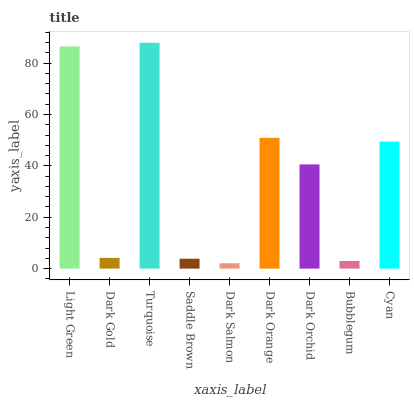Is Dark Salmon the minimum?
Answer yes or no. Yes. Is Turquoise the maximum?
Answer yes or no. Yes. Is Dark Gold the minimum?
Answer yes or no. No. Is Dark Gold the maximum?
Answer yes or no. No. Is Light Green greater than Dark Gold?
Answer yes or no. Yes. Is Dark Gold less than Light Green?
Answer yes or no. Yes. Is Dark Gold greater than Light Green?
Answer yes or no. No. Is Light Green less than Dark Gold?
Answer yes or no. No. Is Dark Orchid the high median?
Answer yes or no. Yes. Is Dark Orchid the low median?
Answer yes or no. Yes. Is Bubblegum the high median?
Answer yes or no. No. Is Light Green the low median?
Answer yes or no. No. 